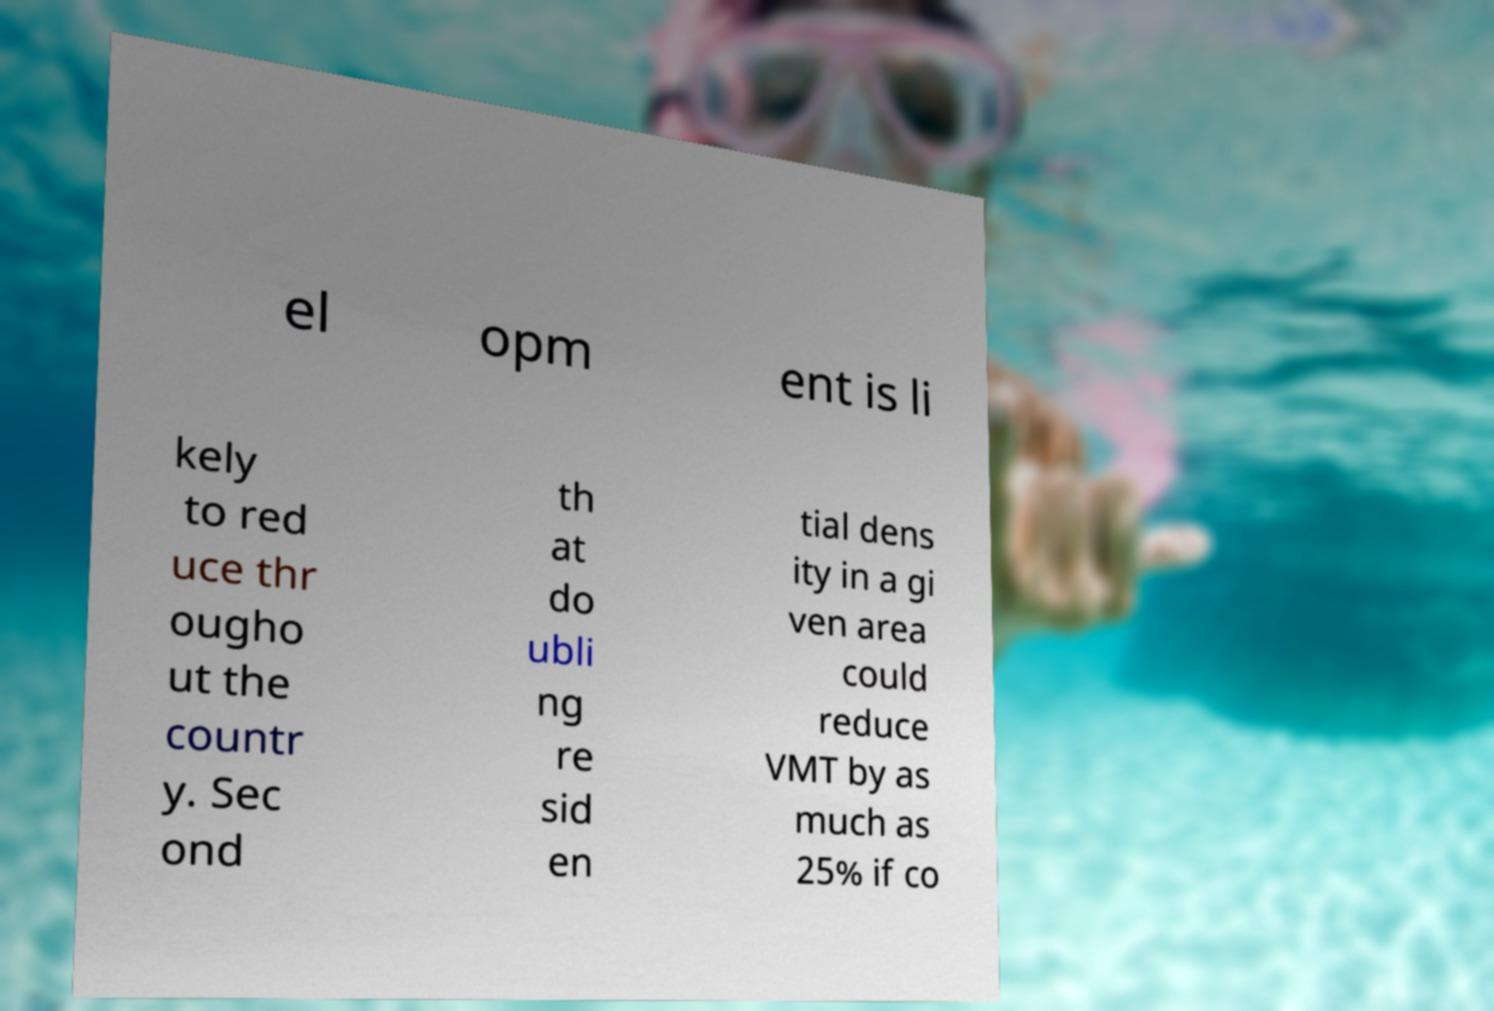I need the written content from this picture converted into text. Can you do that? el opm ent is li kely to red uce thr ougho ut the countr y. Sec ond th at do ubli ng re sid en tial dens ity in a gi ven area could reduce VMT by as much as 25% if co 